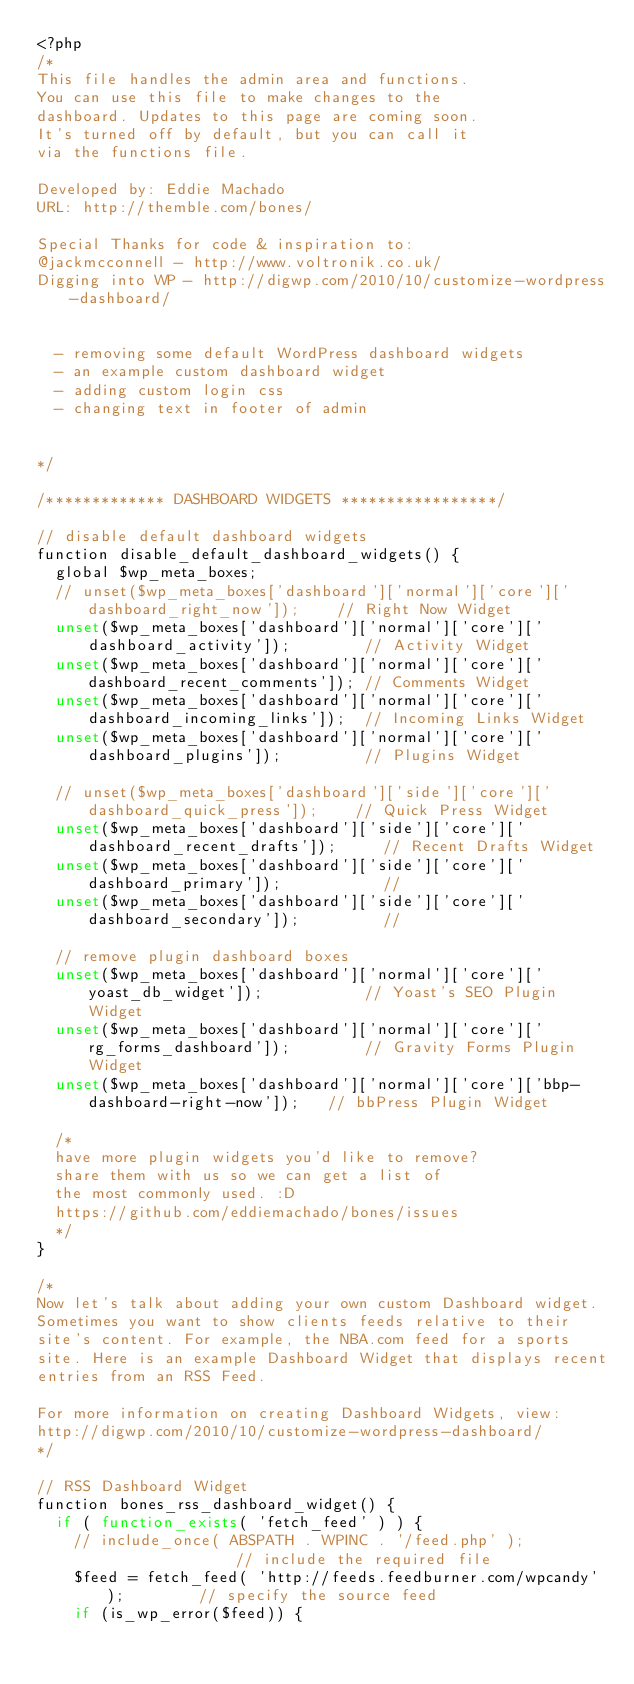Convert code to text. <code><loc_0><loc_0><loc_500><loc_500><_PHP_><?php
/*
This file handles the admin area and functions.
You can use this file to make changes to the
dashboard. Updates to this page are coming soon.
It's turned off by default, but you can call it
via the functions file.

Developed by: Eddie Machado
URL: http://themble.com/bones/

Special Thanks for code & inspiration to:
@jackmcconnell - http://www.voltronik.co.uk/
Digging into WP - http://digwp.com/2010/10/customize-wordpress-dashboard/


	- removing some default WordPress dashboard widgets
	- an example custom dashboard widget
	- adding custom login css
	- changing text in footer of admin


*/

/************* DASHBOARD WIDGETS *****************/

// disable default dashboard widgets
function disable_default_dashboard_widgets() {
	global $wp_meta_boxes;
	// unset($wp_meta_boxes['dashboard']['normal']['core']['dashboard_right_now']);    // Right Now Widget
	unset($wp_meta_boxes['dashboard']['normal']['core']['dashboard_activity']);        // Activity Widget
	unset($wp_meta_boxes['dashboard']['normal']['core']['dashboard_recent_comments']); // Comments Widget
	unset($wp_meta_boxes['dashboard']['normal']['core']['dashboard_incoming_links']);  // Incoming Links Widget
	unset($wp_meta_boxes['dashboard']['normal']['core']['dashboard_plugins']);         // Plugins Widget

	// unset($wp_meta_boxes['dashboard']['side']['core']['dashboard_quick_press']);    // Quick Press Widget
	unset($wp_meta_boxes['dashboard']['side']['core']['dashboard_recent_drafts']);     // Recent Drafts Widget
	unset($wp_meta_boxes['dashboard']['side']['core']['dashboard_primary']);           //
	unset($wp_meta_boxes['dashboard']['side']['core']['dashboard_secondary']);         //

	// remove plugin dashboard boxes
	unset($wp_meta_boxes['dashboard']['normal']['core']['yoast_db_widget']);           // Yoast's SEO Plugin Widget
	unset($wp_meta_boxes['dashboard']['normal']['core']['rg_forms_dashboard']);        // Gravity Forms Plugin Widget
	unset($wp_meta_boxes['dashboard']['normal']['core']['bbp-dashboard-right-now']);   // bbPress Plugin Widget

	/*
	have more plugin widgets you'd like to remove?
	share them with us so we can get a list of
	the most commonly used. :D
	https://github.com/eddiemachado/bones/issues
	*/
}

/*
Now let's talk about adding your own custom Dashboard widget.
Sometimes you want to show clients feeds relative to their
site's content. For example, the NBA.com feed for a sports
site. Here is an example Dashboard Widget that displays recent
entries from an RSS Feed.

For more information on creating Dashboard Widgets, view:
http://digwp.com/2010/10/customize-wordpress-dashboard/
*/

// RSS Dashboard Widget
function bones_rss_dashboard_widget() {
	if ( function_exists( 'fetch_feed' ) ) {
		// include_once( ABSPATH . WPINC . '/feed.php' );               // include the required file
		$feed = fetch_feed( 'http://feeds.feedburner.com/wpcandy' );        // specify the source feed
		if (is_wp_error($feed)) {</code> 